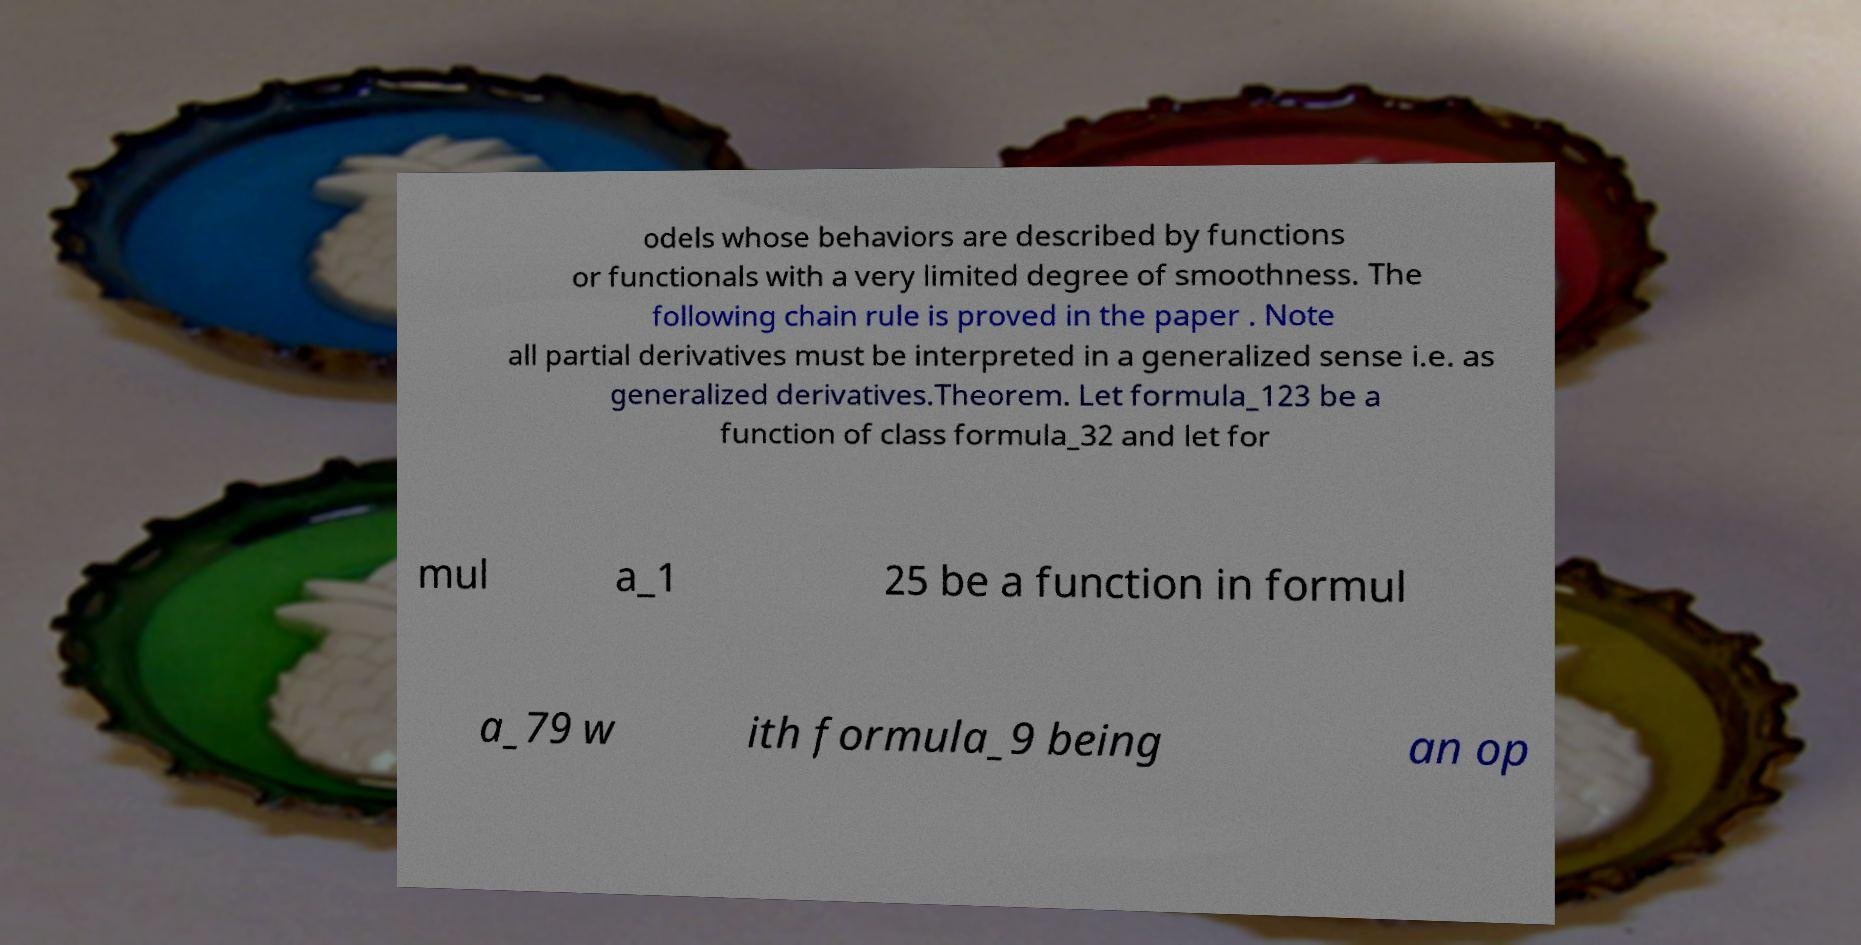Could you assist in decoding the text presented in this image and type it out clearly? odels whose behaviors are described by functions or functionals with a very limited degree of smoothness. The following chain rule is proved in the paper . Note all partial derivatives must be interpreted in a generalized sense i.e. as generalized derivatives.Theorem. Let formula_123 be a function of class formula_32 and let for mul a_1 25 be a function in formul a_79 w ith formula_9 being an op 